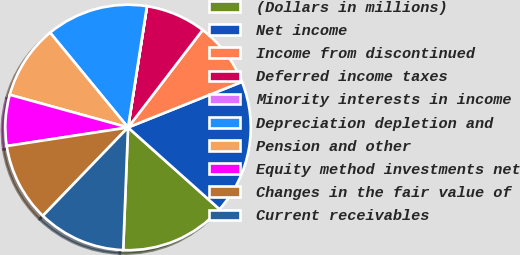Convert chart. <chart><loc_0><loc_0><loc_500><loc_500><pie_chart><fcel>(Dollars in millions)<fcel>Net income<fcel>Income from discontinued<fcel>Deferred income taxes<fcel>Minority interests in income<fcel>Depreciation depletion and<fcel>Pension and other<fcel>Equity method investments net<fcel>Changes in the fair value of<fcel>Current receivables<nl><fcel>14.02%<fcel>17.67%<fcel>8.54%<fcel>7.93%<fcel>0.01%<fcel>13.41%<fcel>9.76%<fcel>6.71%<fcel>10.37%<fcel>11.58%<nl></chart> 